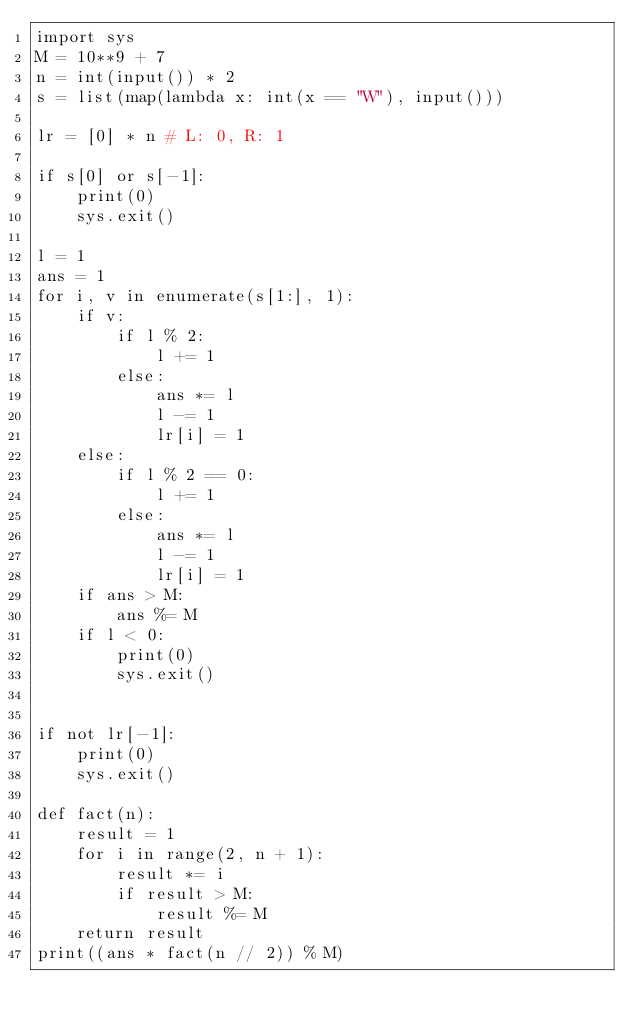<code> <loc_0><loc_0><loc_500><loc_500><_Python_>import sys
M = 10**9 + 7
n = int(input()) * 2
s = list(map(lambda x: int(x == "W"), input()))

lr = [0] * n # L: 0, R: 1

if s[0] or s[-1]:
    print(0)
    sys.exit()

l = 1
ans = 1
for i, v in enumerate(s[1:], 1):
    if v:
        if l % 2:
            l += 1
        else:
            ans *= l
            l -= 1
            lr[i] = 1
    else:
        if l % 2 == 0:
            l += 1
        else:
            ans *= l
            l -= 1
            lr[i] = 1
    if ans > M:
        ans %= M
    if l < 0:
        print(0)
        sys.exit()


if not lr[-1]:
    print(0)
    sys.exit()

def fact(n):
    result = 1
    for i in range(2, n + 1):
        result *= i
        if result > M:
            result %= M
    return result
print((ans * fact(n // 2)) % M)
</code> 